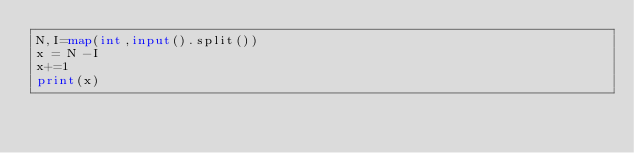Convert code to text. <code><loc_0><loc_0><loc_500><loc_500><_Python_>N,I=map(int,input().split())
x = N -I
x+=1
print(x)</code> 